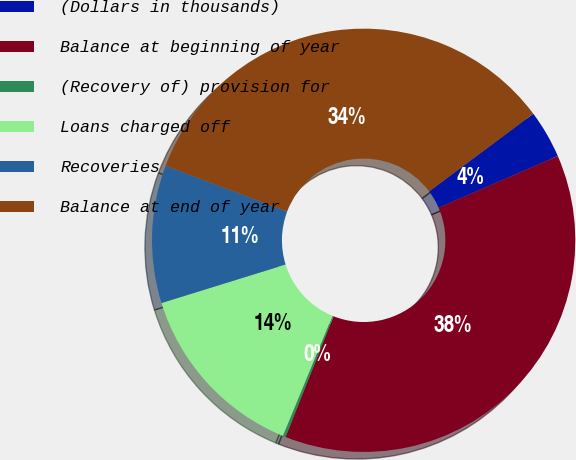Convert chart. <chart><loc_0><loc_0><loc_500><loc_500><pie_chart><fcel>(Dollars in thousands)<fcel>Balance at beginning of year<fcel>(Recovery of) provision for<fcel>Loans charged off<fcel>Recoveries<fcel>Balance at end of year<nl><fcel>3.68%<fcel>37.54%<fcel>0.22%<fcel>13.98%<fcel>10.51%<fcel>34.07%<nl></chart> 